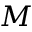<formula> <loc_0><loc_0><loc_500><loc_500>M</formula> 